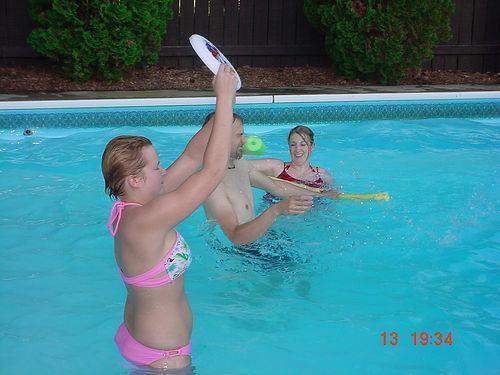How many women are in the pool?
Give a very brief answer. 2. How many people are visible?
Give a very brief answer. 3. 